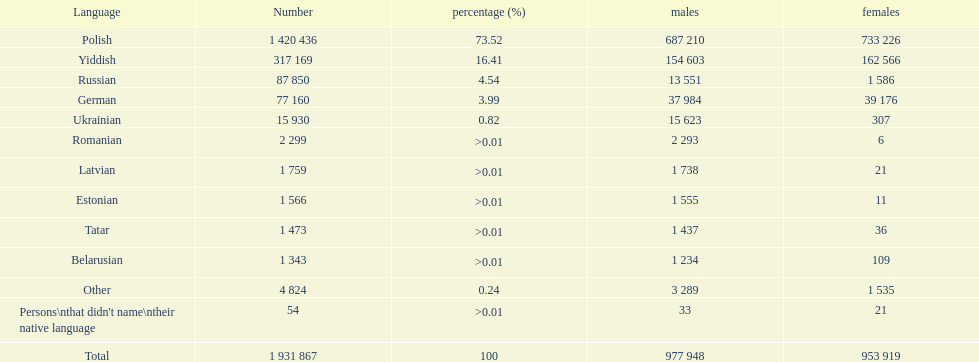01, which one was at the top? Romanian. 